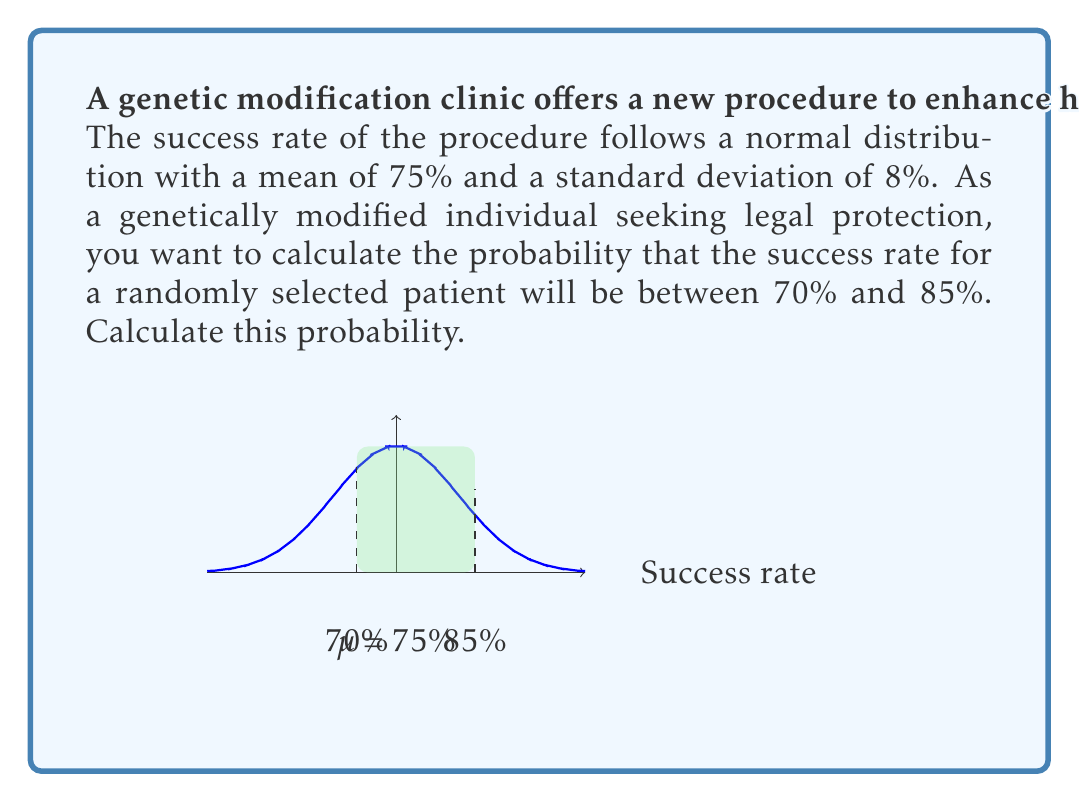Give your solution to this math problem. To solve this problem, we need to use the properties of the normal distribution and calculate the z-scores for the given values.

Step 1: Identify the given information
- Mean ($\mu$) = 75%
- Standard deviation ($\sigma$) = 8%
- Lower bound = 70%
- Upper bound = 85%

Step 2: Calculate the z-scores for both bounds
For the lower bound (70%):
$z_1 = \frac{x - \mu}{\sigma} = \frac{70 - 75}{8} = -0.625$

For the upper bound (85%):
$z_2 = \frac{x - \mu}{\sigma} = \frac{85 - 75}{8} = 1.25$

Step 3: Use a standard normal distribution table or calculator to find the area between these z-scores

The probability is equal to the area under the standard normal curve between $z_1$ and $z_2$.

$P(-0.625 < Z < 1.25) = P(Z < 1.25) - P(Z < -0.625)$

Using a standard normal table or calculator:
$P(Z < 1.25) \approx 0.8944$
$P(Z < -0.625) \approx 0.2660$

Step 4: Calculate the final probability
$P(70\% < X < 85\%) = 0.8944 - 0.2660 \approx 0.6284$

Therefore, the probability that the success rate for a randomly selected patient will be between 70% and 85% is approximately 0.6284 or 62.84%.
Answer: $0.6284$ or $62.84\%$ 